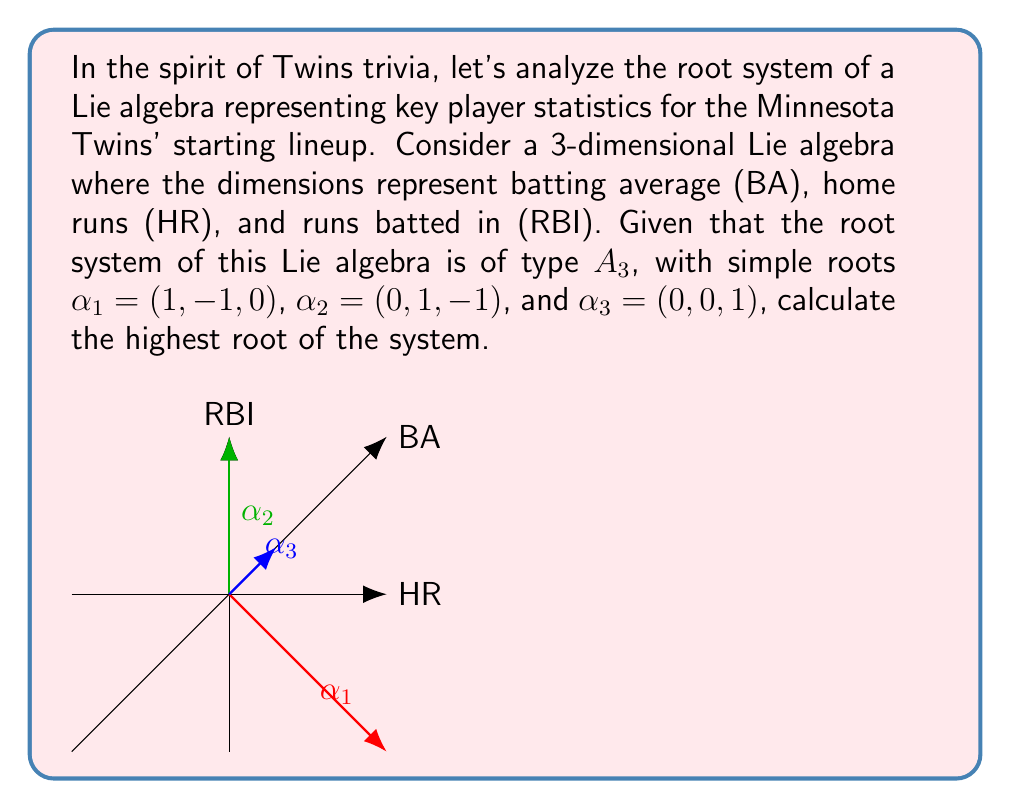Provide a solution to this math problem. Let's approach this step-by-step:

1) In a root system of type $A_3$, the highest root is the sum of all simple roots. So, we need to calculate $\alpha_1 + \alpha_2 + \alpha_3$.

2) Let's add the roots:

   $\alpha_1 = (1, -1, 0)$
   $\alpha_2 = (0, 1, -1)$
   $\alpha_3 = (0, 0, 1)$

   $(1, -1, 0) + (0, 1, -1) + (0, 0, 1)$

3) Adding the first components: $1 + 0 + 0 = 1$
   Adding the second components: $-1 + 1 + 0 = 0$
   Adding the third components: $0 + (-1) + 1 = 0$

4) Therefore, the highest root is $(1, 0, 0)$.

In the context of our Twins statistics Lie algebra, this highest root $(1, 0, 0)$ represents a state where the batting average is at its maximum while home runs and RBIs are balanced. This could be interpreted as a player who excels in getting hits but isn't necessarily a power hitter.
Answer: $(1, 0, 0)$ 